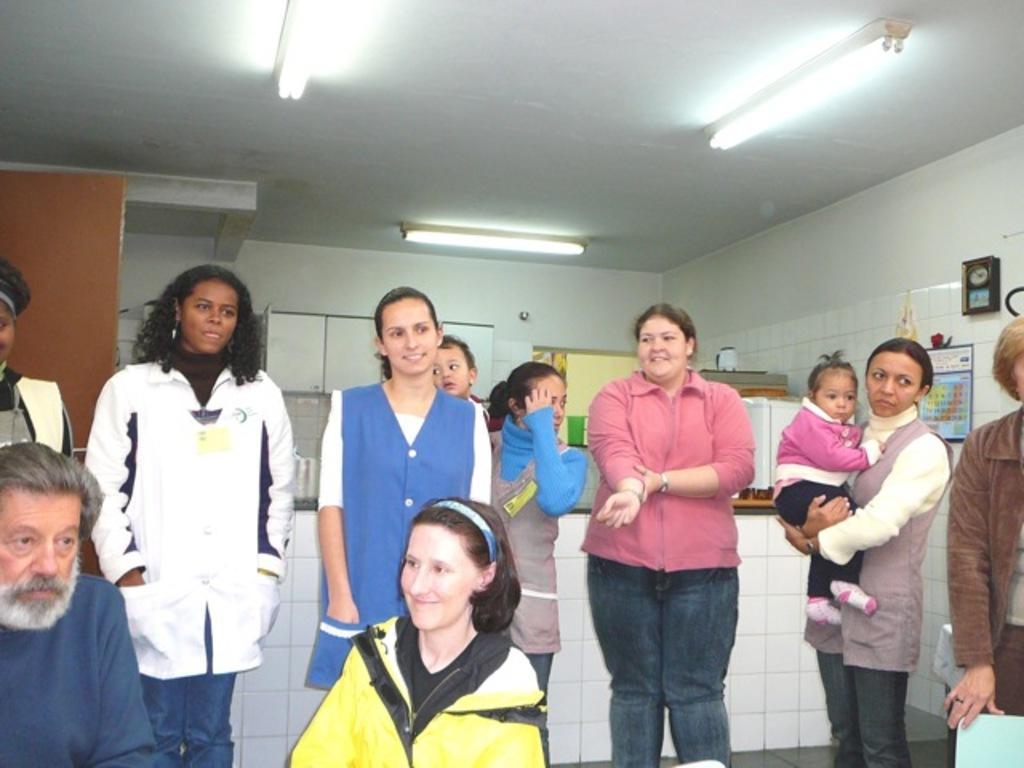Can you describe this image briefly? Here we can see people. This woman is carrying a baby. Clock, calendar and cupboard are on the wall. On that platform there are things. 